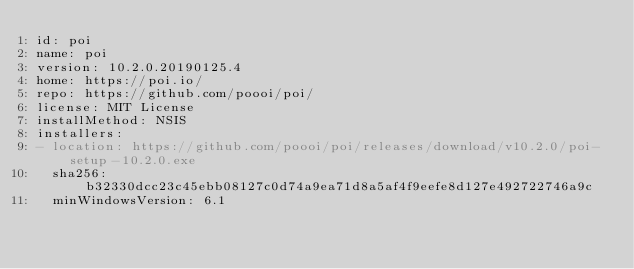<code> <loc_0><loc_0><loc_500><loc_500><_YAML_>id: poi
name: poi
version: 10.2.0.20190125.4
home: https://poi.io/
repo: https://github.com/poooi/poi/
license: MIT License
installMethod: NSIS
installers:
- location: https://github.com/poooi/poi/releases/download/v10.2.0/poi-setup-10.2.0.exe
  sha256: b32330dcc23c45ebb08127c0d74a9ea71d8a5af4f9eefe8d127e492722746a9c
  minWindowsVersion: 6.1
</code> 